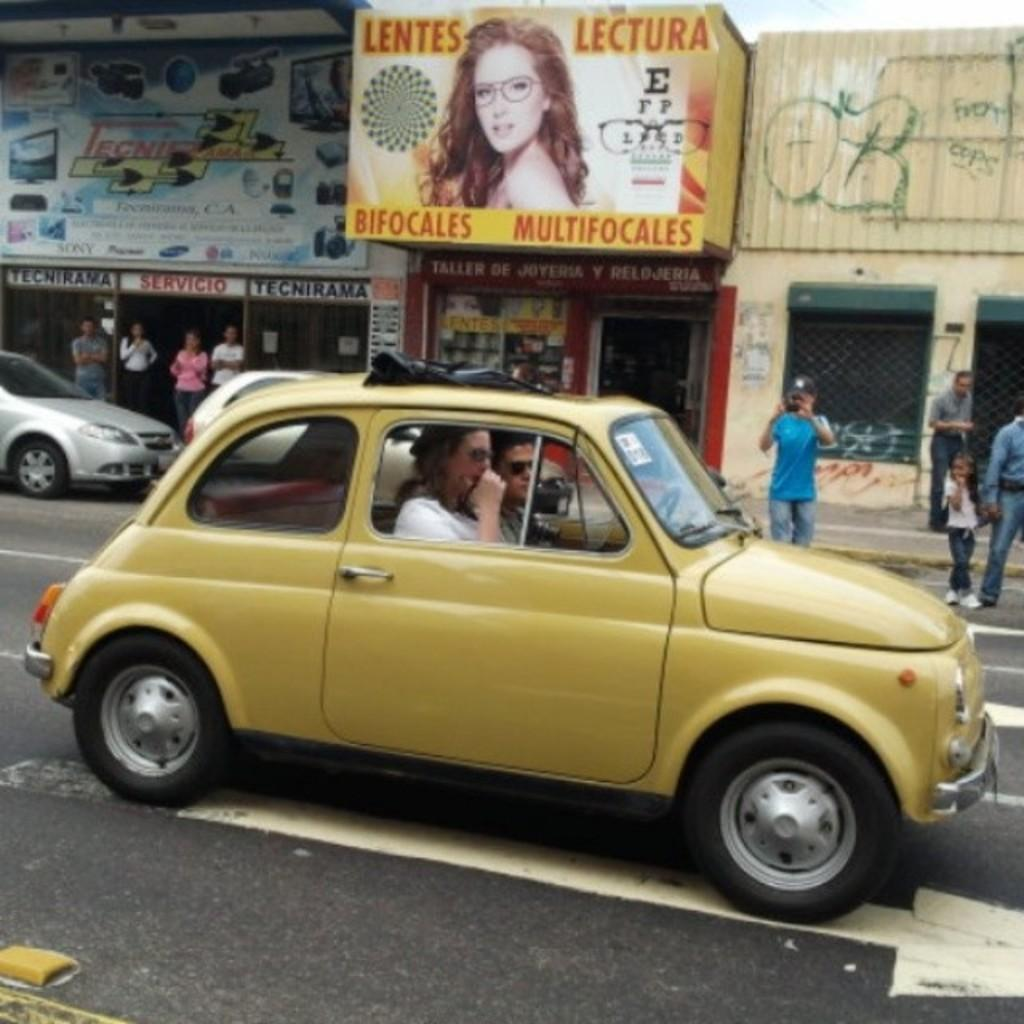What is on the road in the image? There is a car on the road in the image. Who is driving the car? A man and a woman are driving the car. What can be seen on the other side of the road? There is a poster of a woman on the other side of the road. What is happening with the other cars in the image? There are other cars standing at the corner. What type of jelly can be seen on the skirt of the woman in the poster? There is no jelly or skirt present in the image; the poster features a woman without any visible jelly or skirt. 